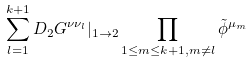Convert formula to latex. <formula><loc_0><loc_0><loc_500><loc_500>\sum _ { l = 1 } ^ { k + 1 } D _ { 2 } G ^ { \nu \nu _ { l } } | _ { 1 \rightarrow 2 } \prod _ { 1 \leq m \leq k + 1 , m \not { = } l } \tilde { \phi } ^ { \mu _ { m } }</formula> 